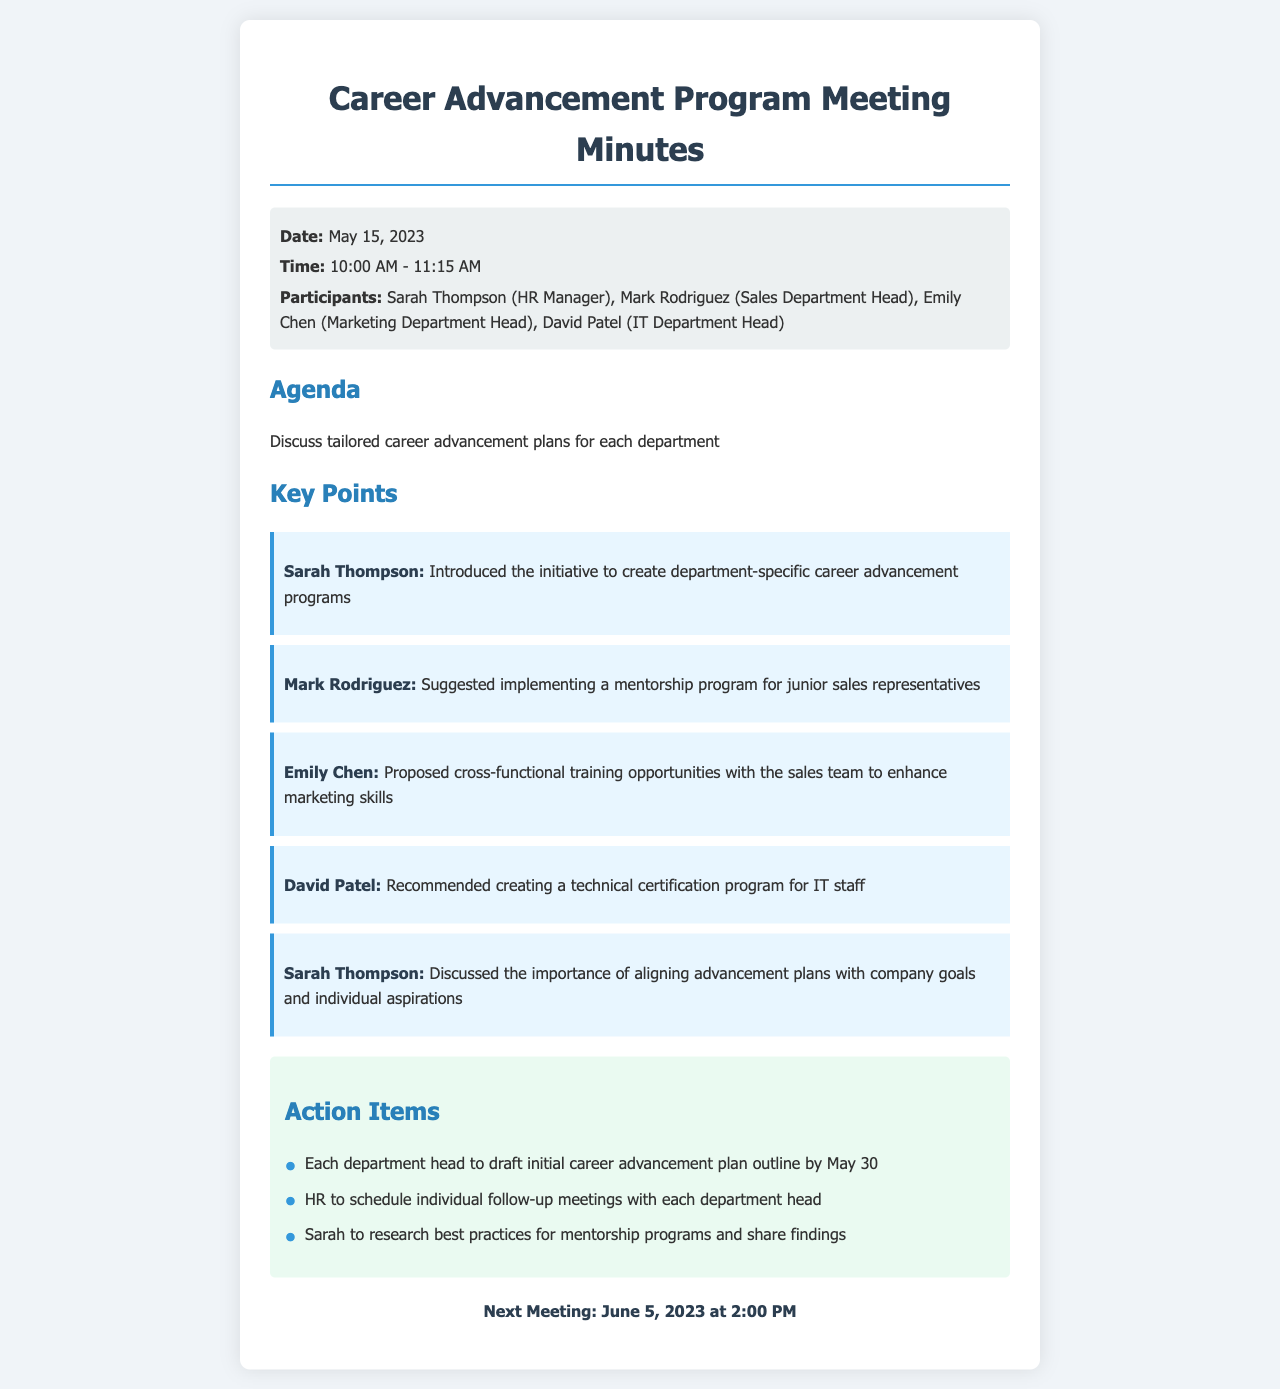What was the date of the meeting? The date of the meeting is specified in the document's meta-info section.
Answer: May 15, 2023 Who is the HR Manager? The HR Manager is mentioned as a participant in the document.
Answer: Sarah Thompson What key program did Mark Rodriguez suggest? Mark Rodriguez's suggestion is detailed in the key points section of the document.
Answer: Mentorship program How many participants were in the meeting? The number of participants can be found in the meta-info section where they are listed.
Answer: Four What is the next meeting date? The next meeting date is clearly stated in the document.
Answer: June 5, 2023 Which department head proposed cross-functional training? The proposal for cross-functional training is attributed to a specific department head in the key points.
Answer: Emily Chen What deadline was set for department heads to draft their plans? The deadline for department heads to draft their plans is found in the action items section.
Answer: May 30 Why is it important to align advancement plans? The document indicates this importance in a statement made by Sarah Thompson.
Answer: Company goals and individual aspirations 